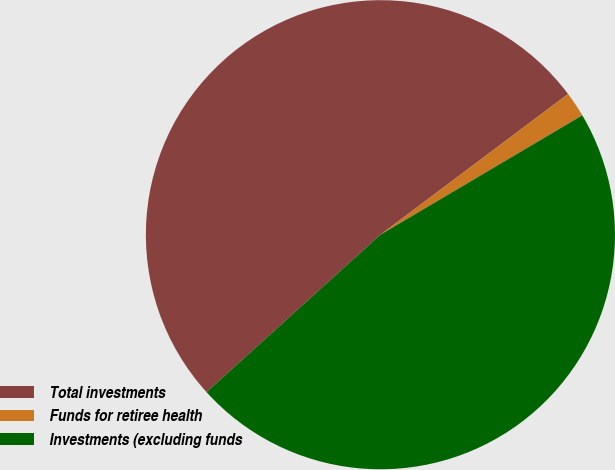Convert chart to OTSL. <chart><loc_0><loc_0><loc_500><loc_500><pie_chart><fcel>Total investments<fcel>Funds for retiree health<fcel>Investments (excluding funds<nl><fcel>51.47%<fcel>1.74%<fcel>46.79%<nl></chart> 